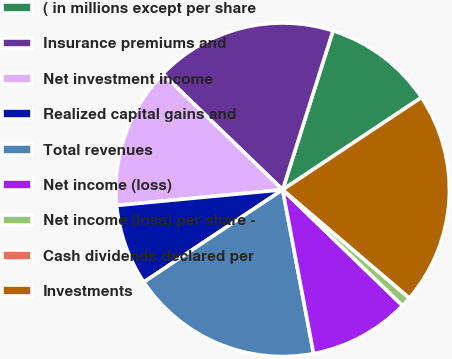<chart> <loc_0><loc_0><loc_500><loc_500><pie_chart><fcel>( in millions except per share<fcel>Insurance premiums and<fcel>Net investment income<fcel>Realized capital gains and<fcel>Total revenues<fcel>Net income (loss)<fcel>Net income (loss) per share -<fcel>Cash dividends declared per<fcel>Investments<nl><fcel>10.78%<fcel>17.65%<fcel>13.73%<fcel>7.84%<fcel>18.63%<fcel>9.8%<fcel>0.98%<fcel>0.0%<fcel>20.59%<nl></chart> 